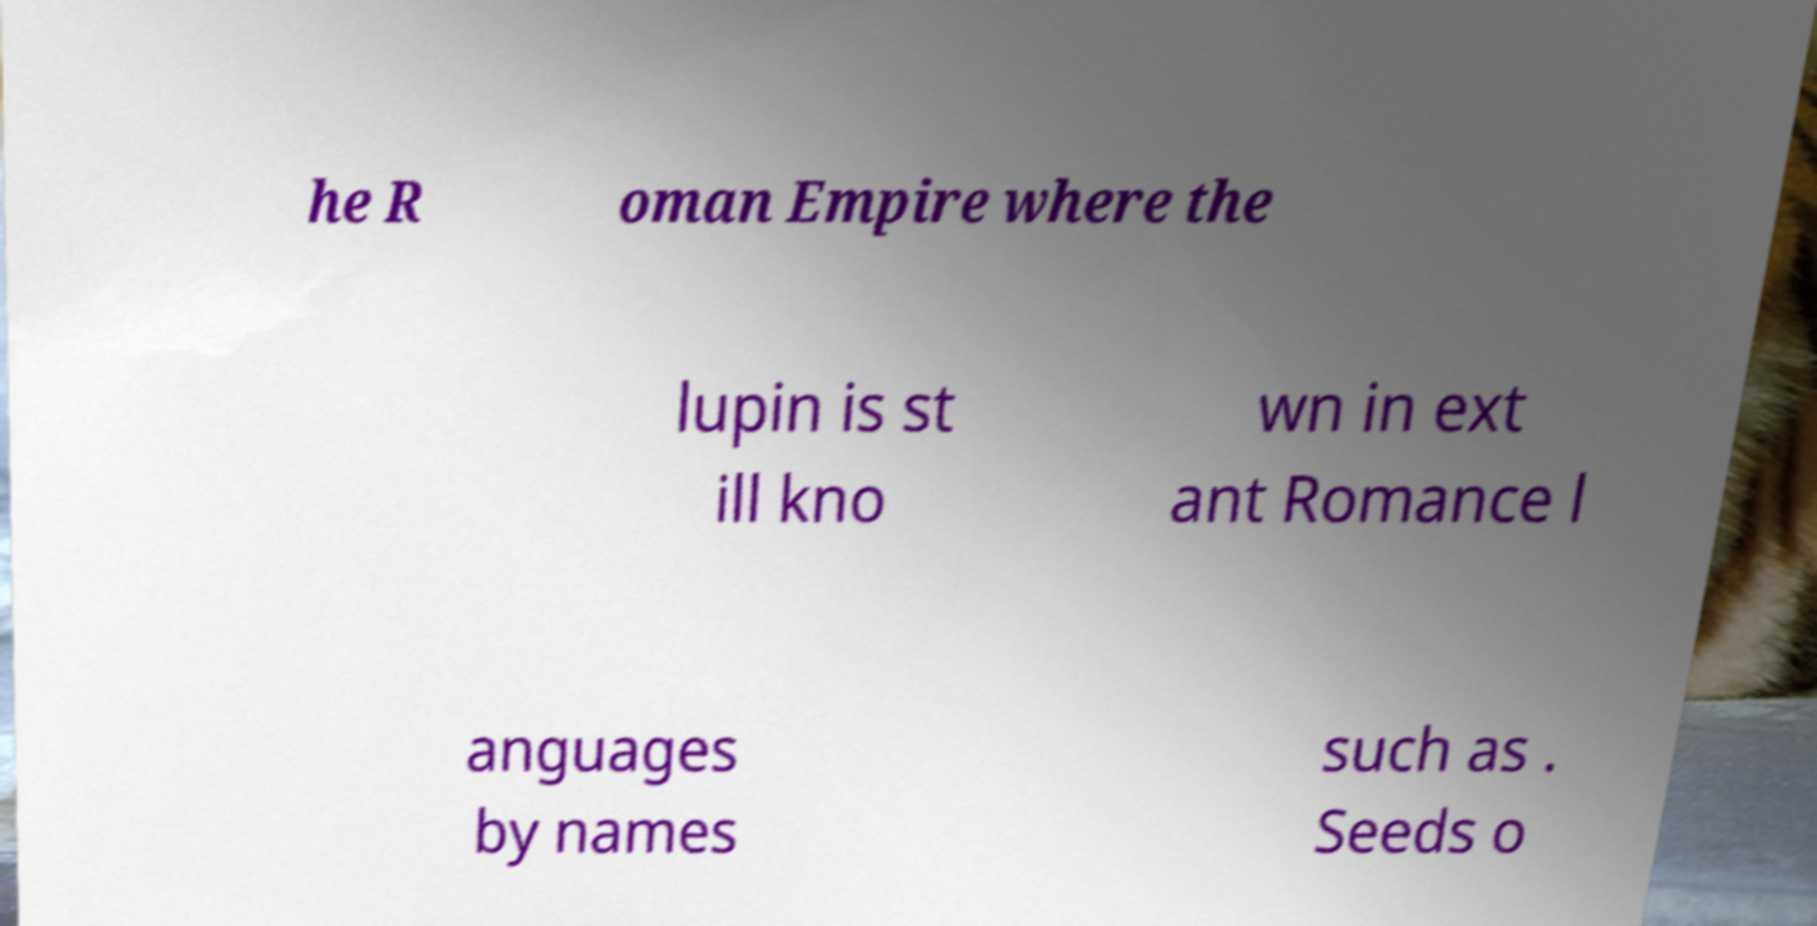I need the written content from this picture converted into text. Can you do that? he R oman Empire where the lupin is st ill kno wn in ext ant Romance l anguages by names such as . Seeds o 